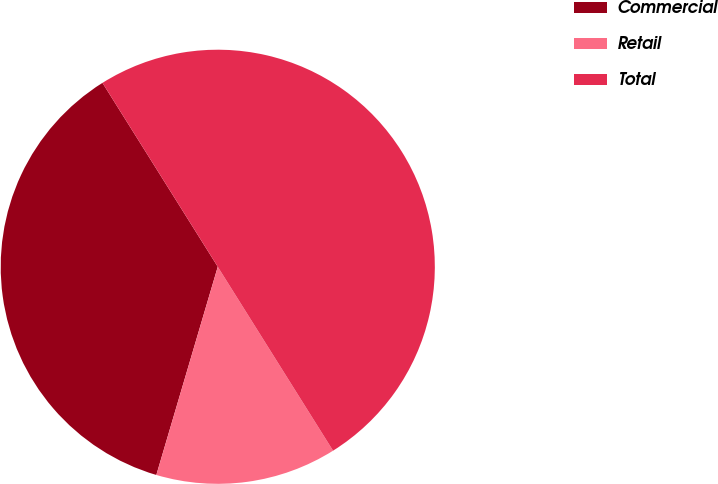<chart> <loc_0><loc_0><loc_500><loc_500><pie_chart><fcel>Commercial<fcel>Retail<fcel>Total<nl><fcel>36.52%<fcel>13.48%<fcel>50.0%<nl></chart> 